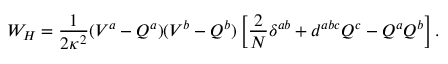Convert formula to latex. <formula><loc_0><loc_0><loc_500><loc_500>W _ { H } = \frac { 1 } { 2 \kappa ^ { 2 } } ( V ^ { a } - Q ^ { a } ) ( V ^ { b } - Q ^ { b } ) \left [ \frac { 2 } { N } \delta ^ { a b } + d ^ { a b c } Q ^ { c } - Q ^ { a } Q ^ { b } \right ] .</formula> 